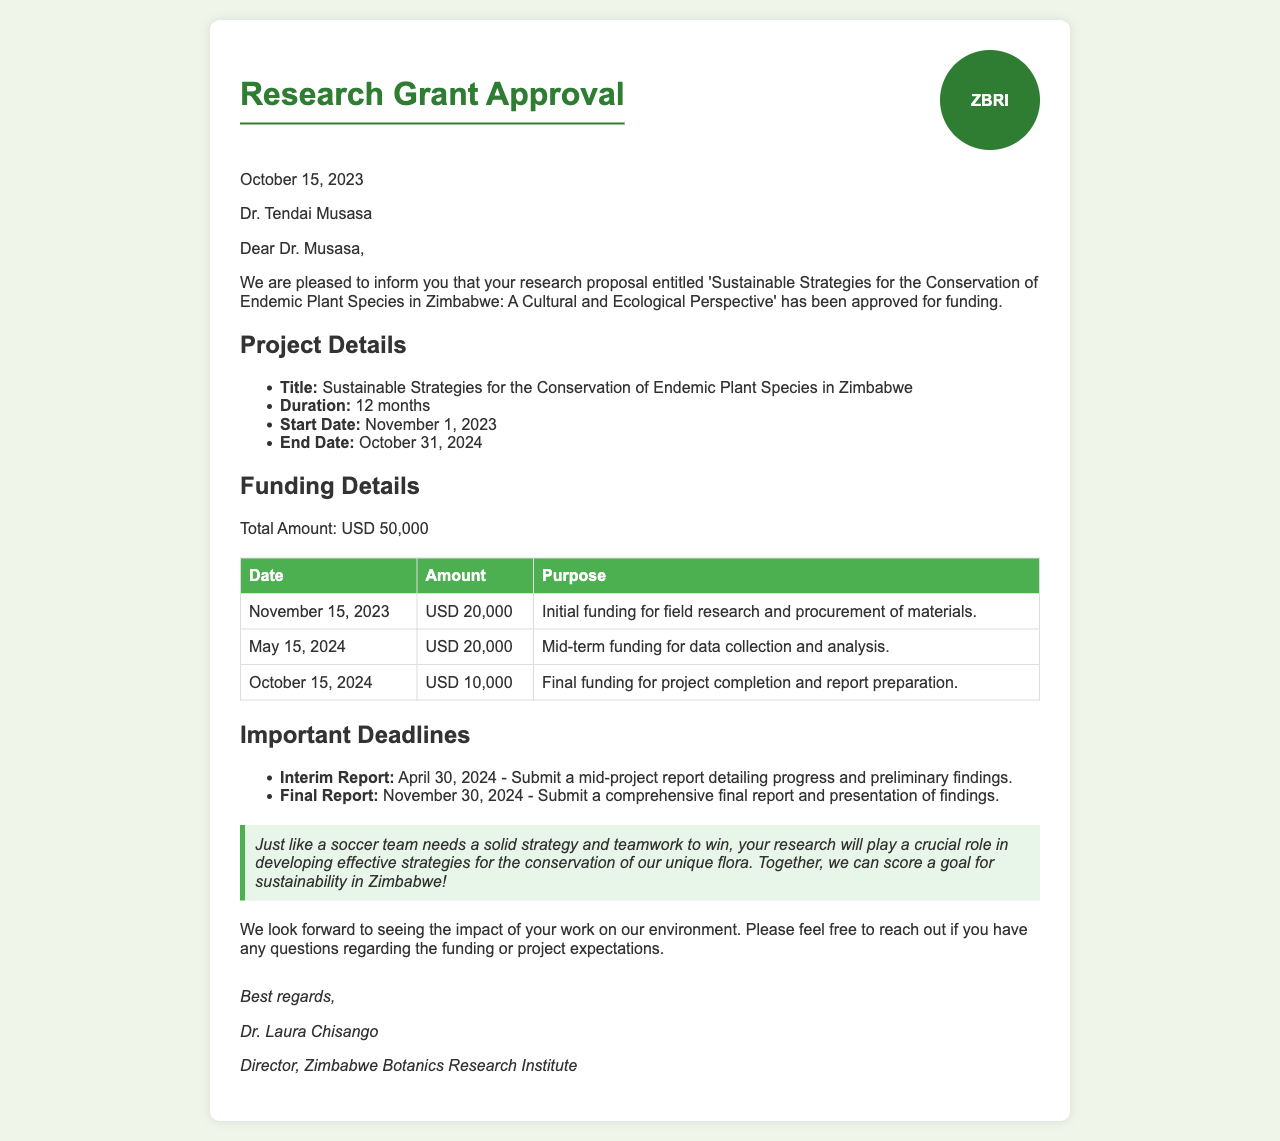What is the title of the research proposal? The title is provided in the project details section of the document.
Answer: Sustainable Strategies for the Conservation of Endemic Plant Species in Zimbabwe What is the total amount of funding approved? The total funding amount is specified in the funding details section.
Answer: USD 50,000 When does the project start? The start date is mentioned in the project details.
Answer: November 1, 2023 What is the date for the interim report submission? The document lists deadlines for reports, including the interim report.
Answer: April 30, 2024 How much funding will be provided on November 15, 2023? The funding table states the amount allocated on this date.
Answer: USD 20,000 What is the purpose of the final funding on October 15, 2024? The funding table describes the use of the final allocation.
Answer: Project completion and report preparation How long is the duration of the project? The duration is mentioned in the project details.
Answer: 12 months What analogy is used in the document related to soccer? The document includes a quote that relates the project's strategy to soccer.
Answer: "Just like a soccer team needs a solid strategy and teamwork to win..." 